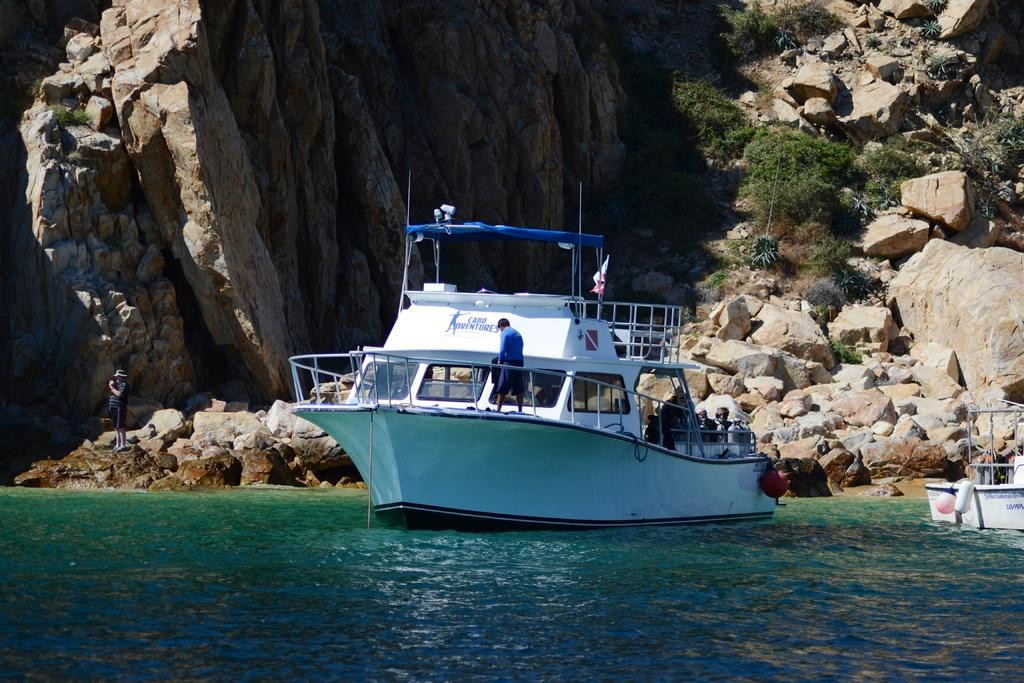<image>
Create a compact narrative representing the image presented. The boat is from the company called Cabo Adventures 